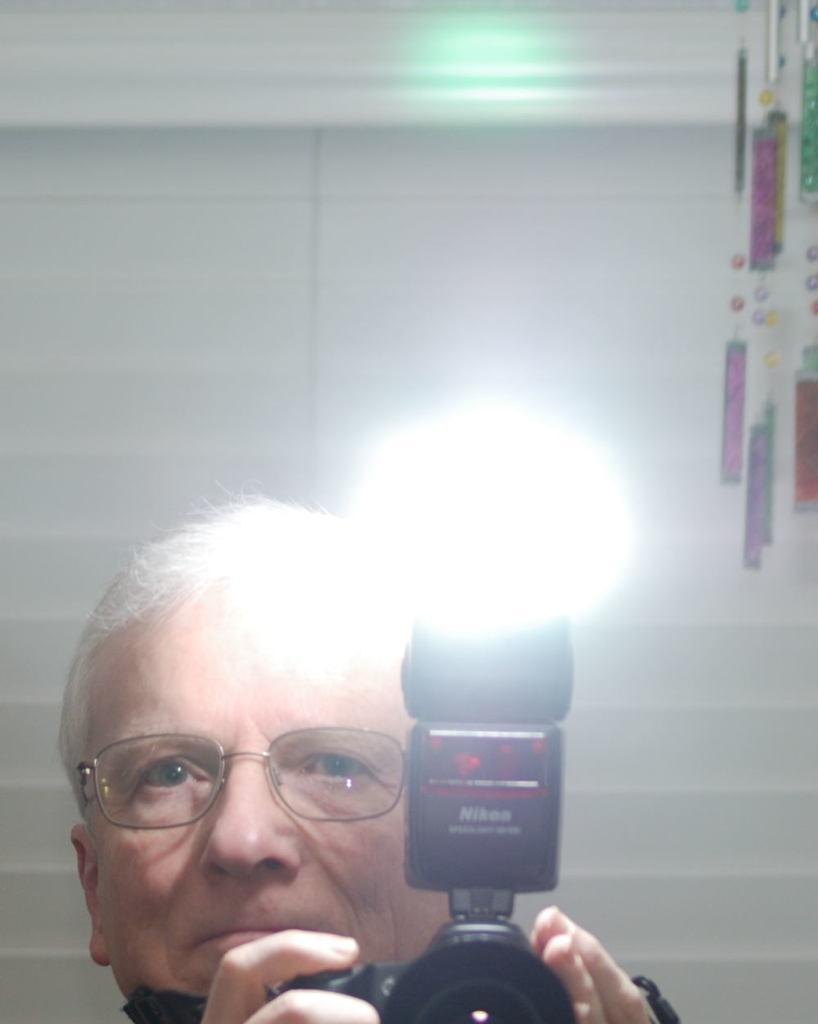Could you give a brief overview of what you see in this image? In this picture there is a man who is wearing spectacle. He is holding camera. At the back we can see the wall. in the top right there is a ropes. 